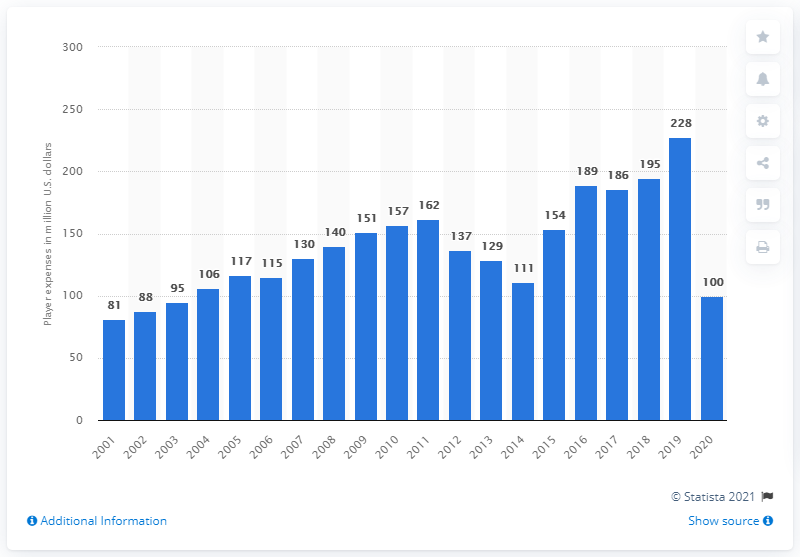Draw attention to some important aspects in this diagram. The payroll of the Chicago Cubs in 2020 was $100 million. 